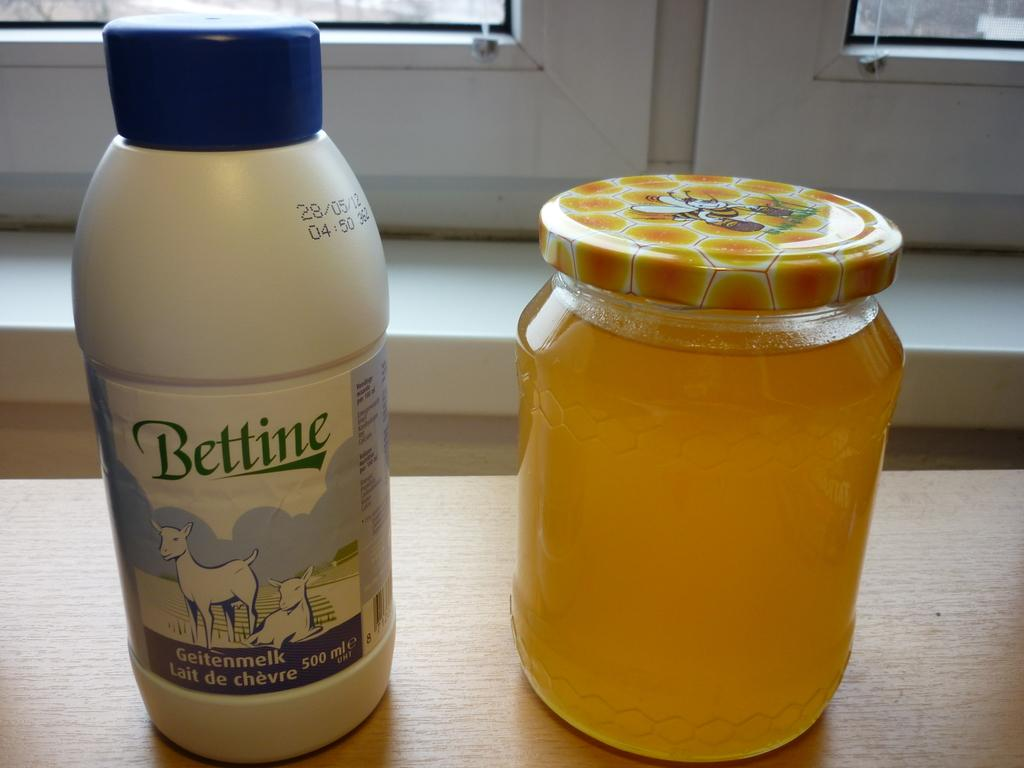What objects are on the table in the image? There is a bottle and a jar on the table in the image. What is on the bottle? There is a sticker on the bottle. What can be seen in the background of the image? There is a glass window in the background. What type of gold appliance is visible on the table in the image? There is no gold appliance present on the table in the image. 